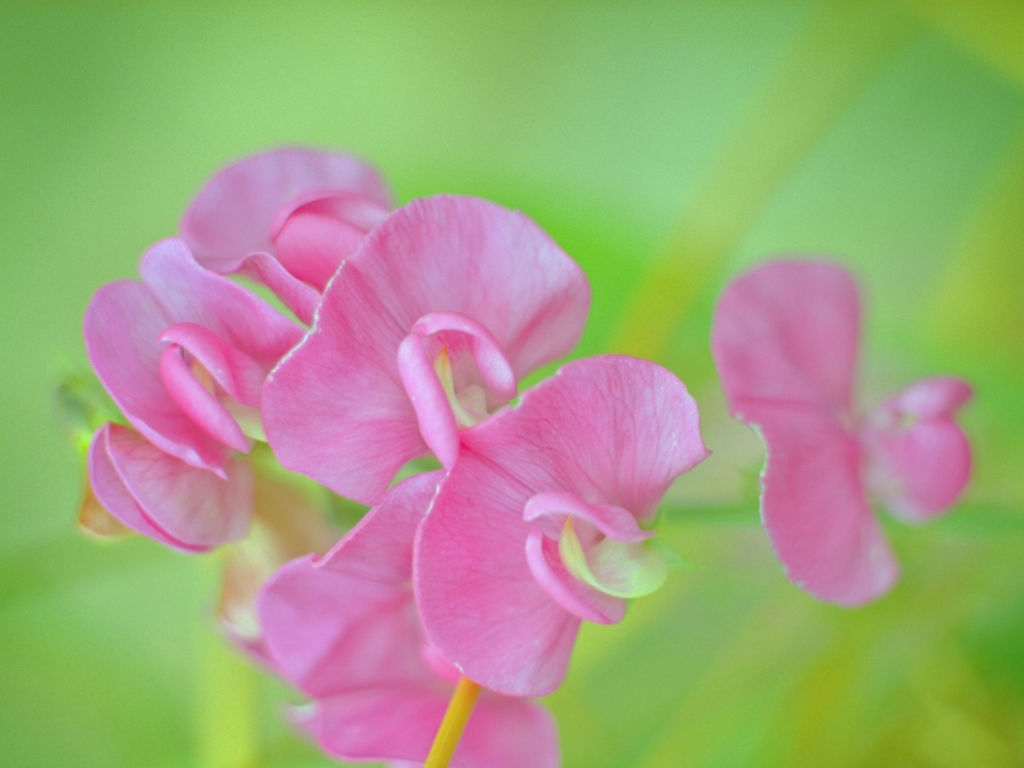How might one cultivate and care for these flowers in a home garden? To cultivate sweet peas, they require well-draining soil, regular watering, and support for climbing, such as a trellis. It's also recommended to plant them in a location that receives ample morning light but is shaded from the intense afternoon sun. Are there any common pests or issues to watch out for? Gardeners should be vigilant about slugs and snails, which can damage young shoots. Additionally, sweet peas can be susceptible to a fungal disease called powdery mildew, especially if the air circulation is poor or if they're overwatered. 